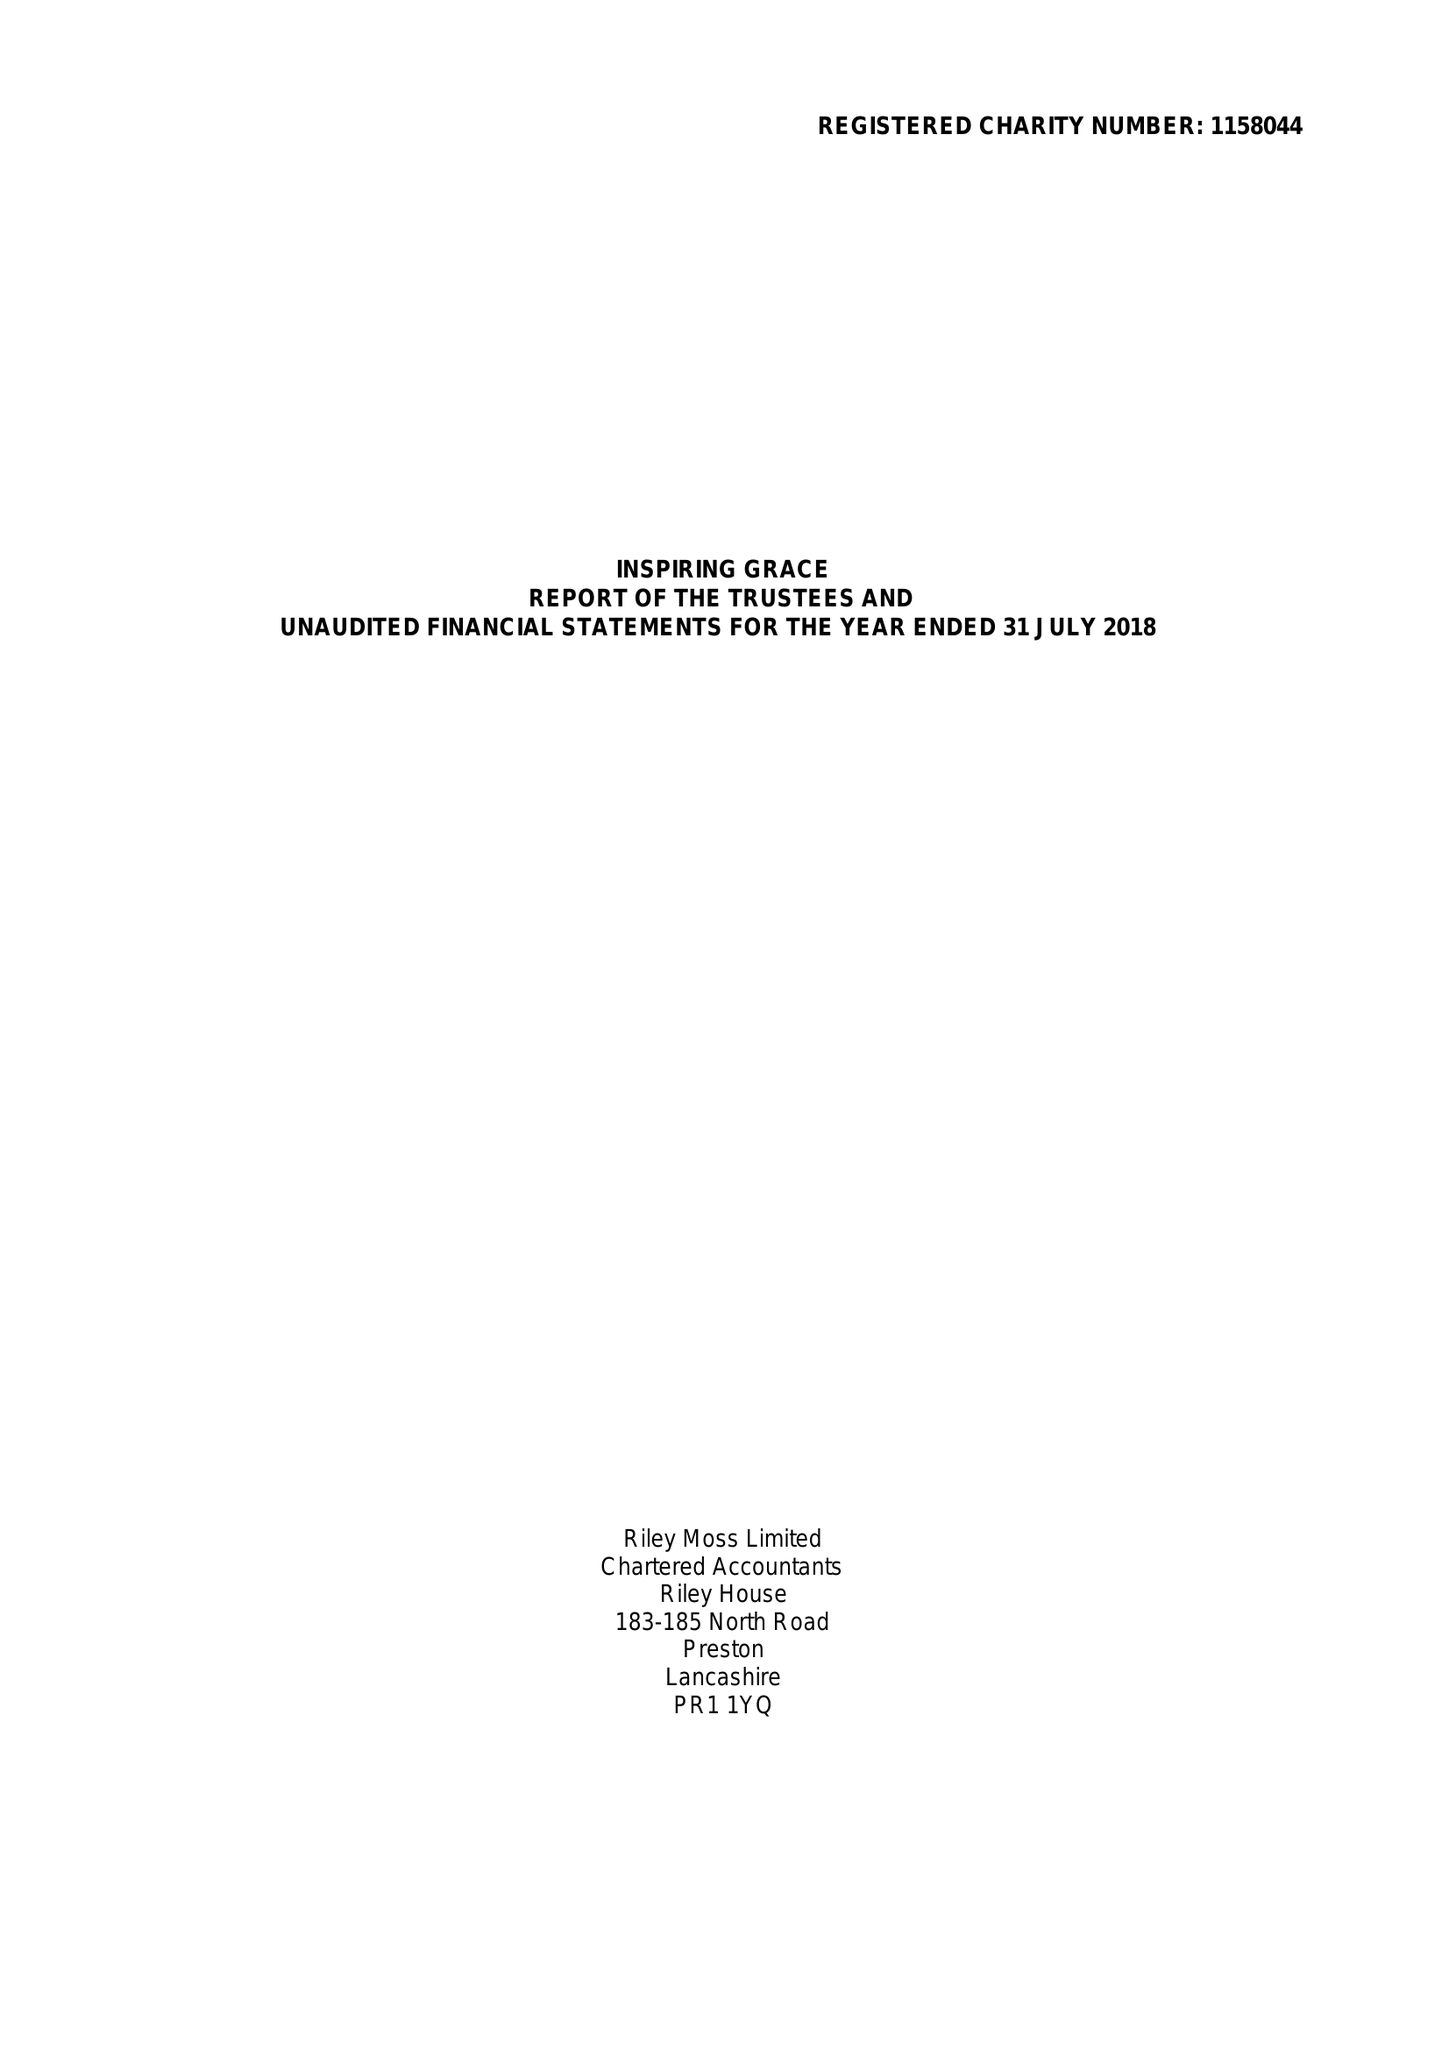What is the value for the charity_number?
Answer the question using a single word or phrase. 1158044 